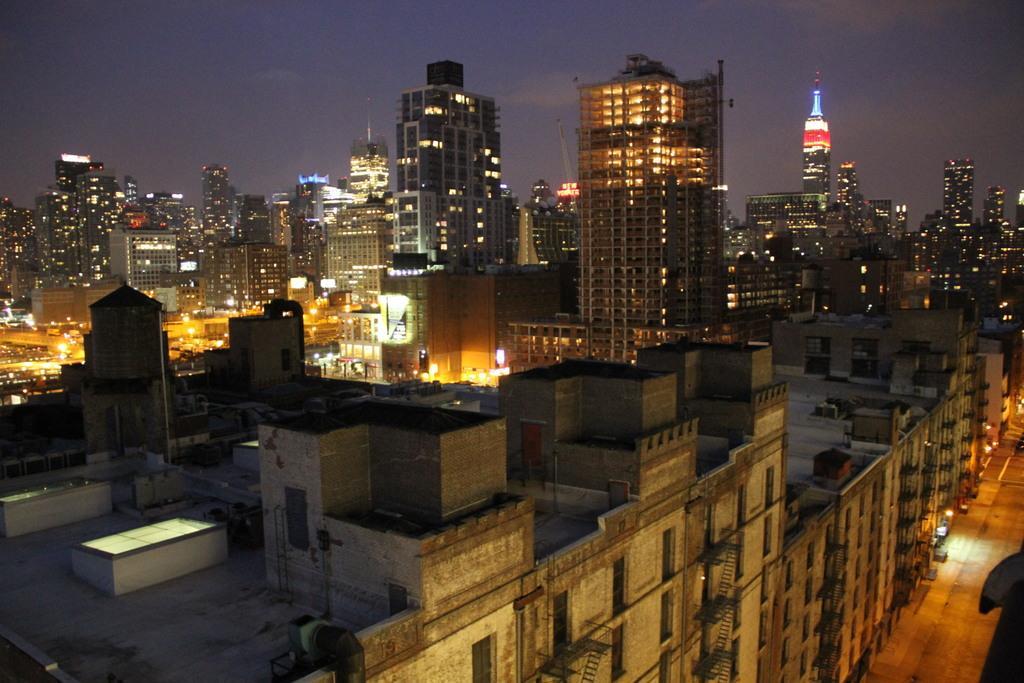Could you give a brief overview of what you see in this image? This picture is clicked outside the city. On the right we can see the ground. On the left we can see the buildings, skyscrapers, minaret and the sky and the lights. 